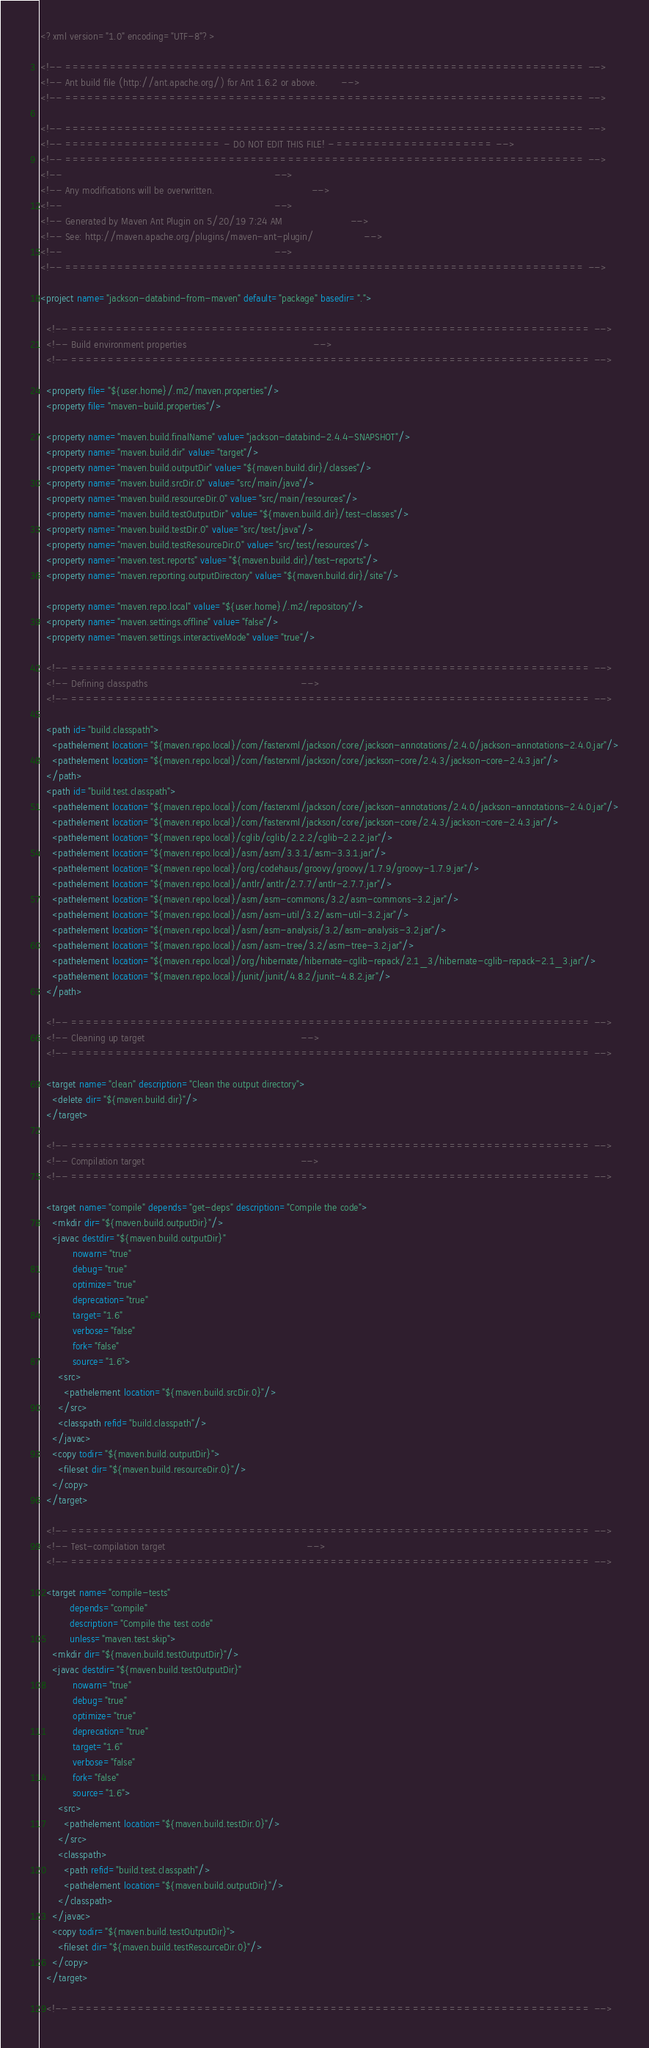<code> <loc_0><loc_0><loc_500><loc_500><_XML_><?xml version="1.0" encoding="UTF-8"?>

<!-- ====================================================================== -->
<!-- Ant build file (http://ant.apache.org/) for Ant 1.6.2 or above.        -->
<!-- ====================================================================== -->

<!-- ====================================================================== -->
<!-- ===================== - DO NOT EDIT THIS FILE! - ===================== -->
<!-- ====================================================================== -->
<!--                                                                        -->
<!-- Any modifications will be overwritten.                                 -->
<!--                                                                        -->
<!-- Generated by Maven Ant Plugin on 5/20/19 7:24 AM                       -->
<!-- See: http://maven.apache.org/plugins/maven-ant-plugin/                 -->
<!--                                                                        -->
<!-- ====================================================================== -->

<project name="jackson-databind-from-maven" default="package" basedir=".">

  <!-- ====================================================================== -->
  <!-- Build environment properties                                           -->
  <!-- ====================================================================== -->

  <property file="${user.home}/.m2/maven.properties"/>
  <property file="maven-build.properties"/>

  <property name="maven.build.finalName" value="jackson-databind-2.4.4-SNAPSHOT"/>
  <property name="maven.build.dir" value="target"/>
  <property name="maven.build.outputDir" value="${maven.build.dir}/classes"/>
  <property name="maven.build.srcDir.0" value="src/main/java"/>
  <property name="maven.build.resourceDir.0" value="src/main/resources"/>
  <property name="maven.build.testOutputDir" value="${maven.build.dir}/test-classes"/>
  <property name="maven.build.testDir.0" value="src/test/java"/>
  <property name="maven.build.testResourceDir.0" value="src/test/resources"/>
  <property name="maven.test.reports" value="${maven.build.dir}/test-reports"/>
  <property name="maven.reporting.outputDirectory" value="${maven.build.dir}/site"/>

  <property name="maven.repo.local" value="${user.home}/.m2/repository"/>
  <property name="maven.settings.offline" value="false"/>
  <property name="maven.settings.interactiveMode" value="true"/>

  <!-- ====================================================================== -->
  <!-- Defining classpaths                                                    -->
  <!-- ====================================================================== -->

  <path id="build.classpath">
    <pathelement location="${maven.repo.local}/com/fasterxml/jackson/core/jackson-annotations/2.4.0/jackson-annotations-2.4.0.jar"/>
    <pathelement location="${maven.repo.local}/com/fasterxml/jackson/core/jackson-core/2.4.3/jackson-core-2.4.3.jar"/>
  </path>
  <path id="build.test.classpath">
    <pathelement location="${maven.repo.local}/com/fasterxml/jackson/core/jackson-annotations/2.4.0/jackson-annotations-2.4.0.jar"/>
    <pathelement location="${maven.repo.local}/com/fasterxml/jackson/core/jackson-core/2.4.3/jackson-core-2.4.3.jar"/>
    <pathelement location="${maven.repo.local}/cglib/cglib/2.2.2/cglib-2.2.2.jar"/>
    <pathelement location="${maven.repo.local}/asm/asm/3.3.1/asm-3.3.1.jar"/>
    <pathelement location="${maven.repo.local}/org/codehaus/groovy/groovy/1.7.9/groovy-1.7.9.jar"/>
    <pathelement location="${maven.repo.local}/antlr/antlr/2.7.7/antlr-2.7.7.jar"/>
    <pathelement location="${maven.repo.local}/asm/asm-commons/3.2/asm-commons-3.2.jar"/>
    <pathelement location="${maven.repo.local}/asm/asm-util/3.2/asm-util-3.2.jar"/>
    <pathelement location="${maven.repo.local}/asm/asm-analysis/3.2/asm-analysis-3.2.jar"/>
    <pathelement location="${maven.repo.local}/asm/asm-tree/3.2/asm-tree-3.2.jar"/>
    <pathelement location="${maven.repo.local}/org/hibernate/hibernate-cglib-repack/2.1_3/hibernate-cglib-repack-2.1_3.jar"/>
    <pathelement location="${maven.repo.local}/junit/junit/4.8.2/junit-4.8.2.jar"/>
  </path>

  <!-- ====================================================================== -->
  <!-- Cleaning up target                                                     -->
  <!-- ====================================================================== -->

  <target name="clean" description="Clean the output directory">
    <delete dir="${maven.build.dir}"/>
  </target>

  <!-- ====================================================================== -->
  <!-- Compilation target                                                     -->
  <!-- ====================================================================== -->

  <target name="compile" depends="get-deps" description="Compile the code">
    <mkdir dir="${maven.build.outputDir}"/>
    <javac destdir="${maven.build.outputDir}" 
           nowarn="true" 
           debug="true" 
           optimize="true" 
           deprecation="true" 
           target="1.6" 
           verbose="false" 
           fork="false" 
           source="1.6">
      <src>
        <pathelement location="${maven.build.srcDir.0}"/>
      </src>
      <classpath refid="build.classpath"/>
    </javac>
    <copy todir="${maven.build.outputDir}">
      <fileset dir="${maven.build.resourceDir.0}"/>
    </copy>
  </target>

  <!-- ====================================================================== -->
  <!-- Test-compilation target                                                -->
  <!-- ====================================================================== -->

  <target name="compile-tests" 
          depends="compile" 
          description="Compile the test code" 
          unless="maven.test.skip">
    <mkdir dir="${maven.build.testOutputDir}"/>
    <javac destdir="${maven.build.testOutputDir}" 
           nowarn="true" 
           debug="true" 
           optimize="true" 
           deprecation="true" 
           target="1.6" 
           verbose="false" 
           fork="false" 
           source="1.6">
      <src>
        <pathelement location="${maven.build.testDir.0}"/>
      </src>
      <classpath>
        <path refid="build.test.classpath"/>
        <pathelement location="${maven.build.outputDir}"/>
      </classpath>
    </javac>
    <copy todir="${maven.build.testOutputDir}">
      <fileset dir="${maven.build.testResourceDir.0}"/>
    </copy>
  </target>

  <!-- ====================================================================== --></code> 